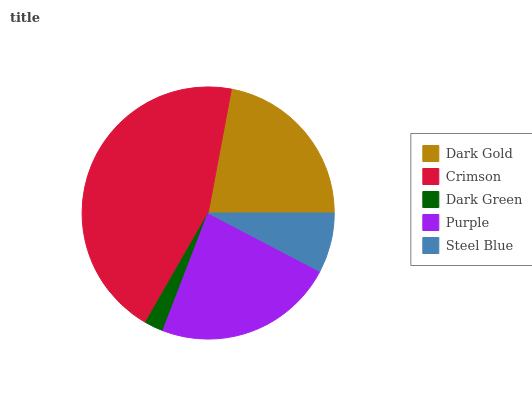Is Dark Green the minimum?
Answer yes or no. Yes. Is Crimson the maximum?
Answer yes or no. Yes. Is Crimson the minimum?
Answer yes or no. No. Is Dark Green the maximum?
Answer yes or no. No. Is Crimson greater than Dark Green?
Answer yes or no. Yes. Is Dark Green less than Crimson?
Answer yes or no. Yes. Is Dark Green greater than Crimson?
Answer yes or no. No. Is Crimson less than Dark Green?
Answer yes or no. No. Is Dark Gold the high median?
Answer yes or no. Yes. Is Dark Gold the low median?
Answer yes or no. Yes. Is Dark Green the high median?
Answer yes or no. No. Is Steel Blue the low median?
Answer yes or no. No. 